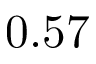<formula> <loc_0><loc_0><loc_500><loc_500>0 . 5 7</formula> 